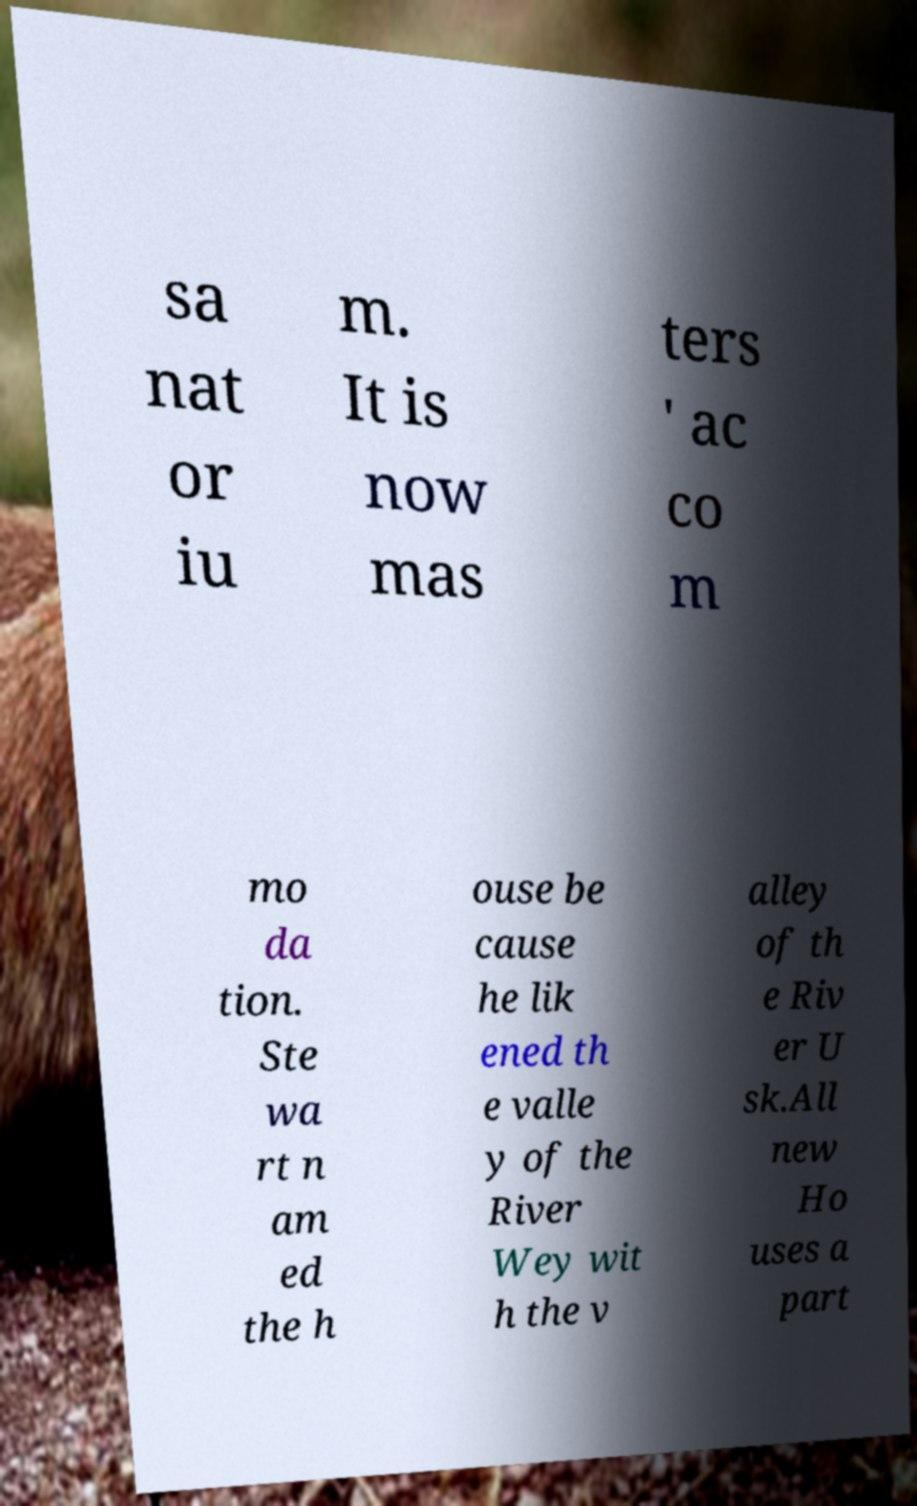I need the written content from this picture converted into text. Can you do that? sa nat or iu m. It is now mas ters ' ac co m mo da tion. Ste wa rt n am ed the h ouse be cause he lik ened th e valle y of the River Wey wit h the v alley of th e Riv er U sk.All new Ho uses a part 